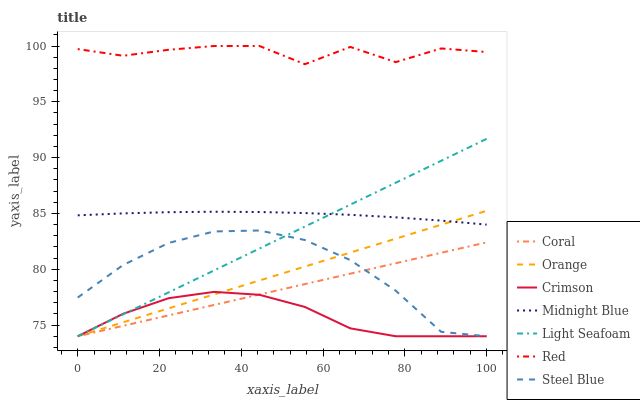Does Crimson have the minimum area under the curve?
Answer yes or no. Yes. Does Red have the maximum area under the curve?
Answer yes or no. Yes. Does Coral have the minimum area under the curve?
Answer yes or no. No. Does Coral have the maximum area under the curve?
Answer yes or no. No. Is Orange the smoothest?
Answer yes or no. Yes. Is Red the roughest?
Answer yes or no. Yes. Is Coral the smoothest?
Answer yes or no. No. Is Coral the roughest?
Answer yes or no. No. Does Red have the lowest value?
Answer yes or no. No. Does Red have the highest value?
Answer yes or no. Yes. Does Coral have the highest value?
Answer yes or no. No. Is Light Seafoam less than Red?
Answer yes or no. Yes. Is Red greater than Midnight Blue?
Answer yes or no. Yes. Does Midnight Blue intersect Light Seafoam?
Answer yes or no. Yes. Is Midnight Blue less than Light Seafoam?
Answer yes or no. No. Is Midnight Blue greater than Light Seafoam?
Answer yes or no. No. Does Light Seafoam intersect Red?
Answer yes or no. No. 